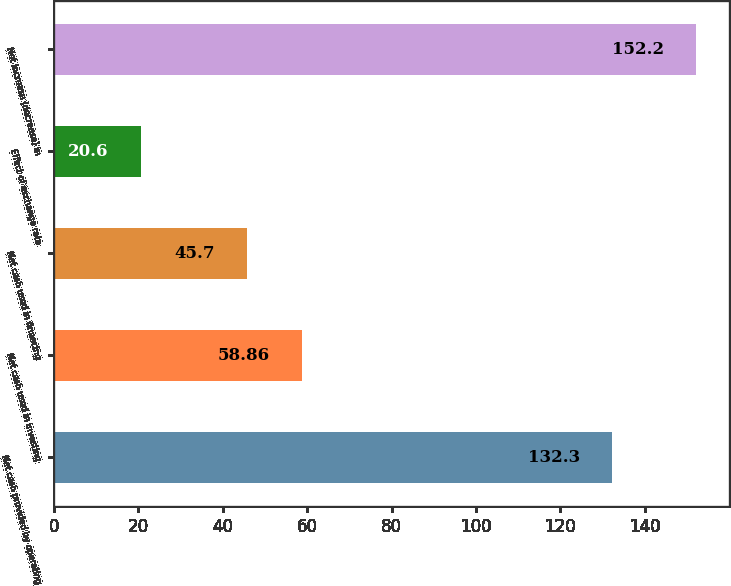<chart> <loc_0><loc_0><loc_500><loc_500><bar_chart><fcel>Net cash provided by operating<fcel>Net cash used in investing<fcel>Net cash used in financing<fcel>Effect of exchange rate<fcel>Net increase (decrease) in<nl><fcel>132.3<fcel>58.86<fcel>45.7<fcel>20.6<fcel>152.2<nl></chart> 